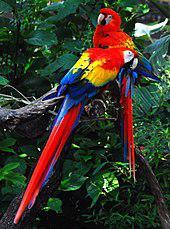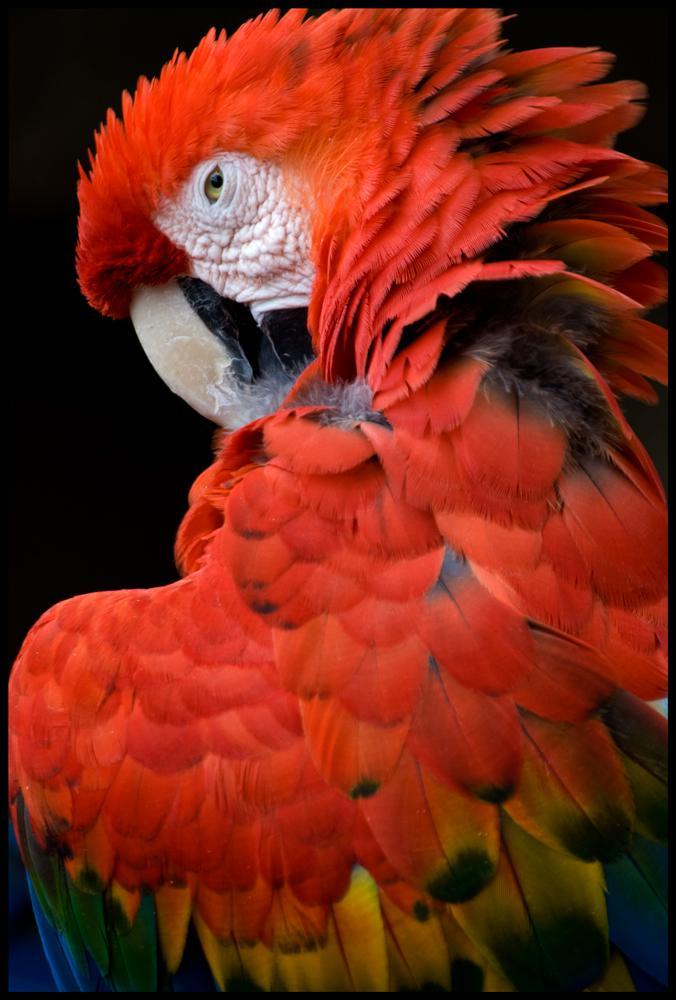The first image is the image on the left, the second image is the image on the right. Given the left and right images, does the statement "The left image contains two parrots perched on a branch." hold true? Answer yes or no. Yes. 